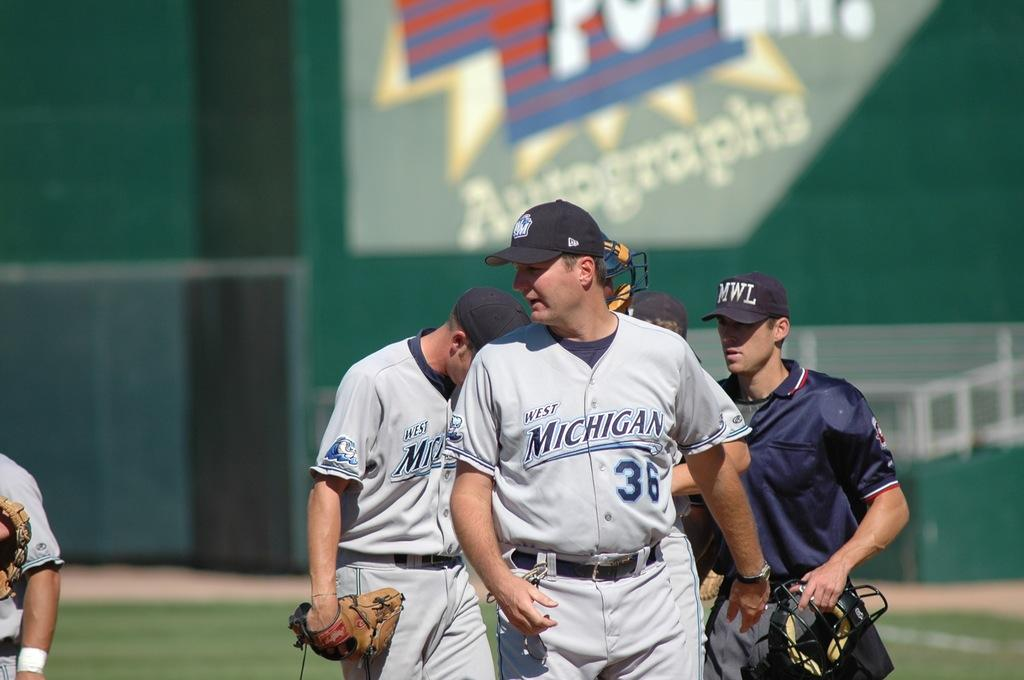Provide a one-sentence caption for the provided image. A baseball game with the West Michigan Whitecaps with three players and two umpires on the field. 